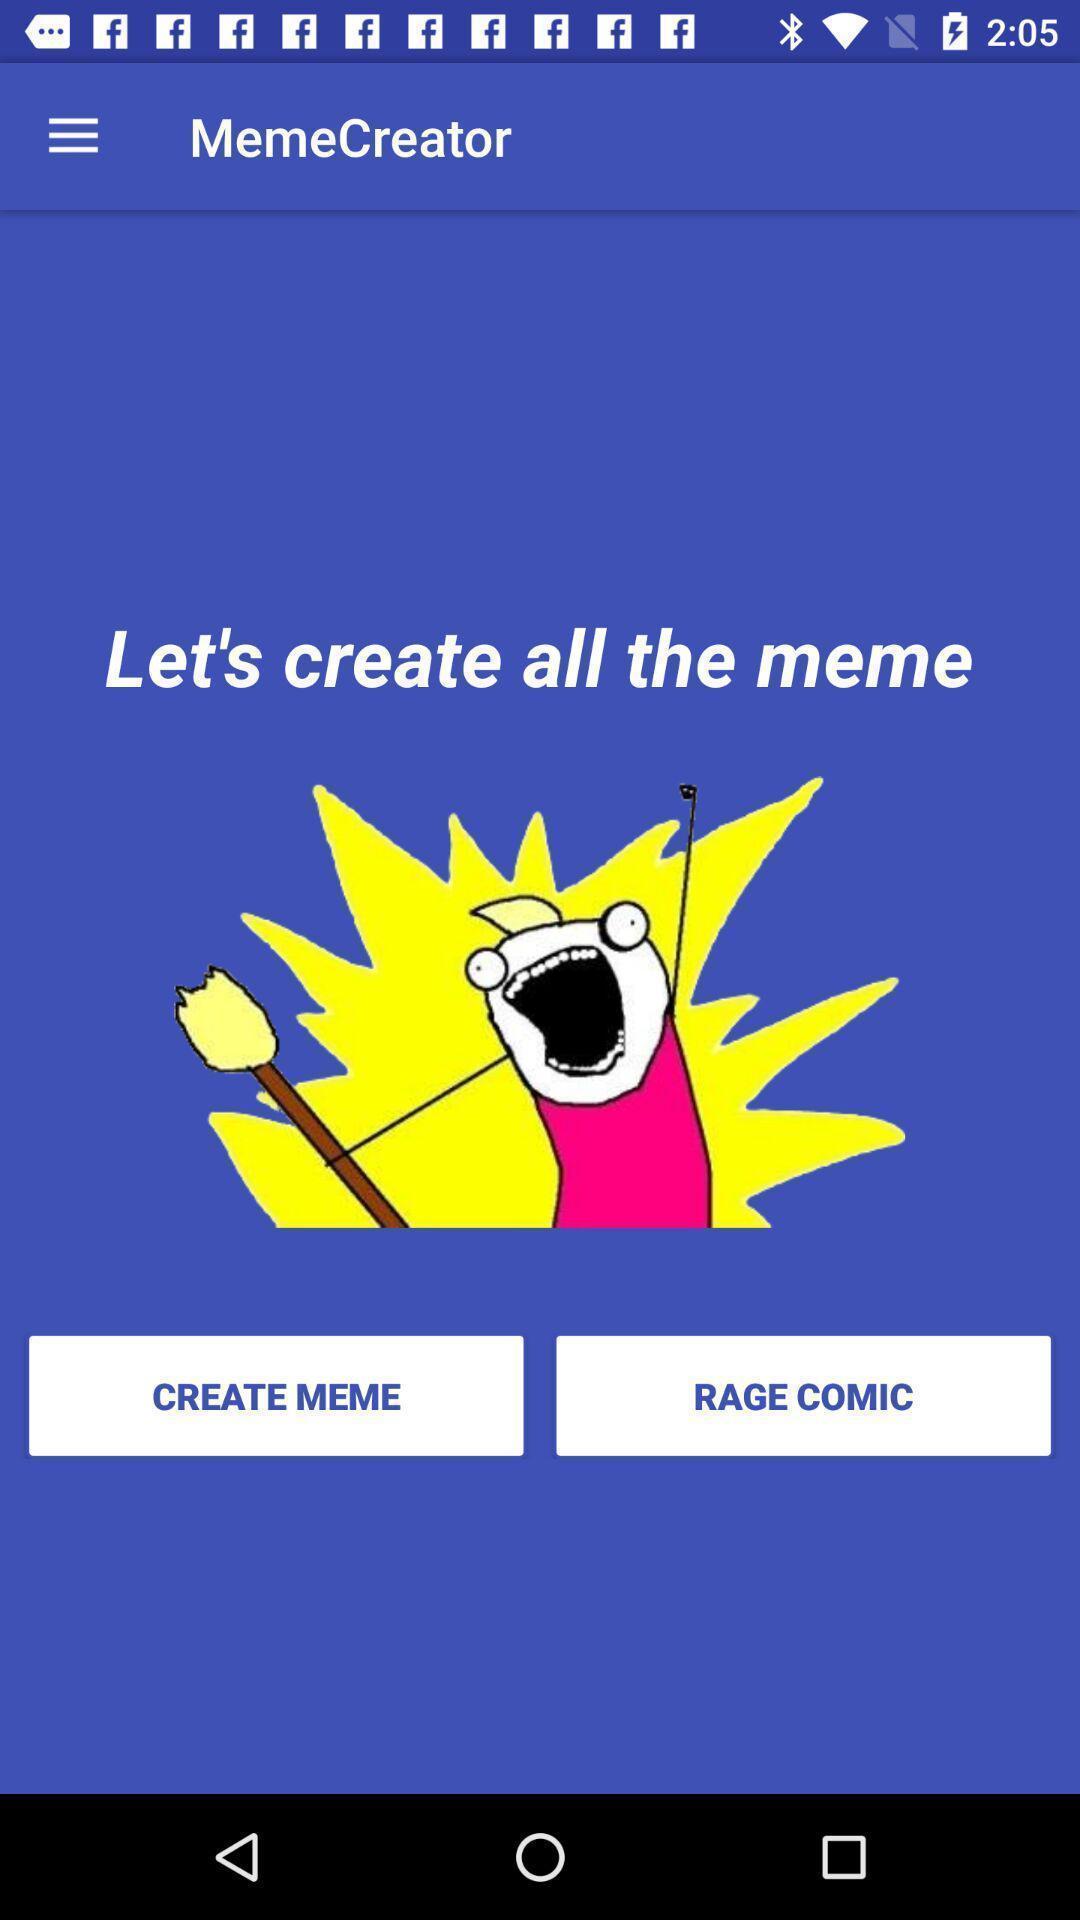Describe the visual elements of this screenshot. Welcome page for a meme creating app. 